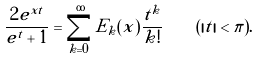Convert formula to latex. <formula><loc_0><loc_0><loc_500><loc_500>\frac { 2 e ^ { x t } } { e ^ { t } + 1 } = \sum _ { k = 0 } ^ { \infty } E _ { k } ( x ) \frac { t ^ { k } } { k ! } \quad ( | t | < \pi ) .</formula> 